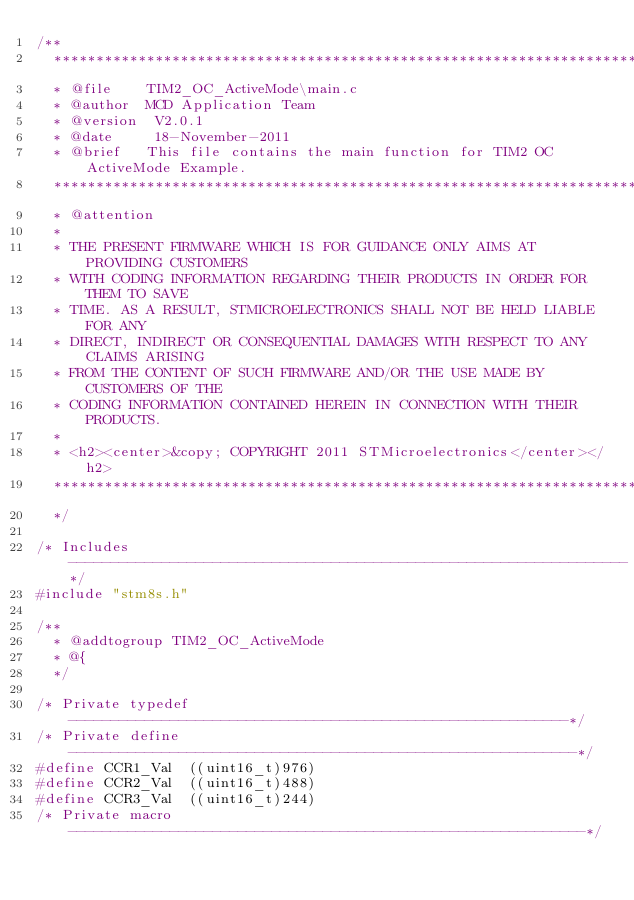<code> <loc_0><loc_0><loc_500><loc_500><_C_>/**
  ******************************************************************************
  * @file    TIM2_OC_ActiveMode\main.c
  * @author  MCD Application Team
  * @version  V2.0.1
  * @date     18-November-2011
  * @brief   This file contains the main function for TIM2 OC ActiveMode Example.
  ******************************************************************************
  * @attention
  *
  * THE PRESENT FIRMWARE WHICH IS FOR GUIDANCE ONLY AIMS AT PROVIDING CUSTOMERS
  * WITH CODING INFORMATION REGARDING THEIR PRODUCTS IN ORDER FOR THEM TO SAVE
  * TIME. AS A RESULT, STMICROELECTRONICS SHALL NOT BE HELD LIABLE FOR ANY
  * DIRECT, INDIRECT OR CONSEQUENTIAL DAMAGES WITH RESPECT TO ANY CLAIMS ARISING
  * FROM THE CONTENT OF SUCH FIRMWARE AND/OR THE USE MADE BY CUSTOMERS OF THE
  * CODING INFORMATION CONTAINED HEREIN IN CONNECTION WITH THEIR PRODUCTS.
  *
  * <h2><center>&copy; COPYRIGHT 2011 STMicroelectronics</center></h2>
  ******************************************************************************
  */ 

/* Includes ------------------------------------------------------------------*/
#include "stm8s.h"

/**
  * @addtogroup TIM2_OC_ActiveMode
  * @{
  */

/* Private typedef -----------------------------------------------------------*/
/* Private define ------------------------------------------------------------*/
#define CCR1_Val  ((uint16_t)976)
#define CCR2_Val  ((uint16_t)488)
#define CCR3_Val  ((uint16_t)244)
/* Private macro -------------------------------------------------------------*/</code> 